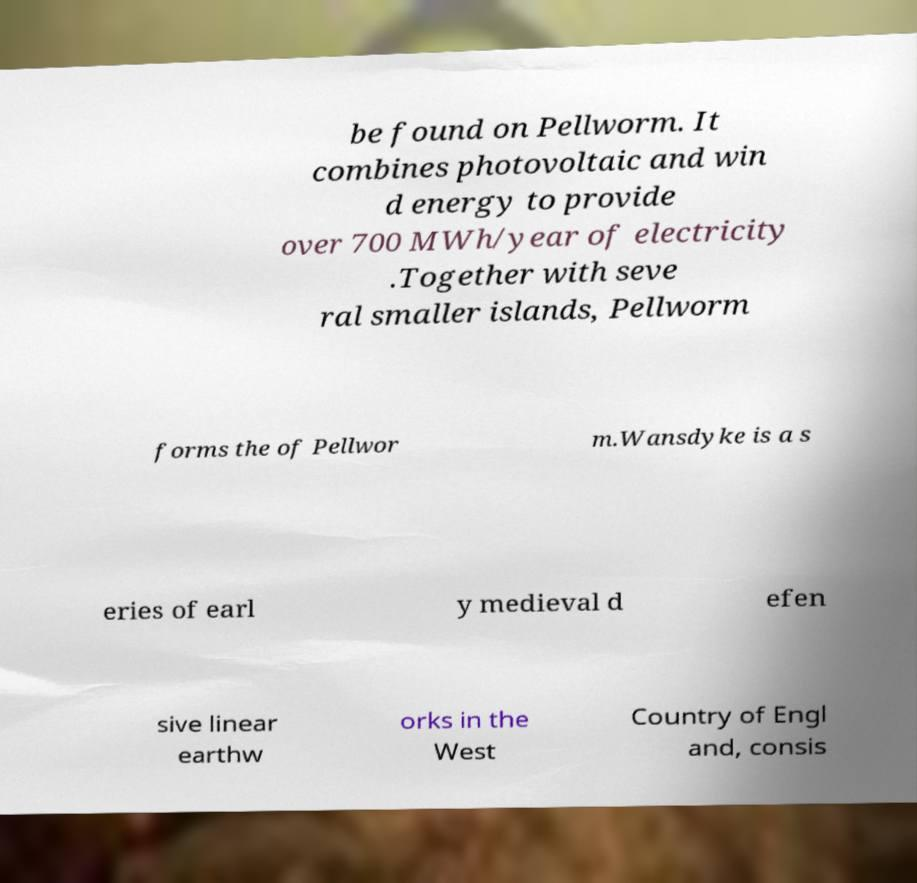I need the written content from this picture converted into text. Can you do that? be found on Pellworm. It combines photovoltaic and win d energy to provide over 700 MWh/year of electricity .Together with seve ral smaller islands, Pellworm forms the of Pellwor m.Wansdyke is a s eries of earl y medieval d efen sive linear earthw orks in the West Country of Engl and, consis 